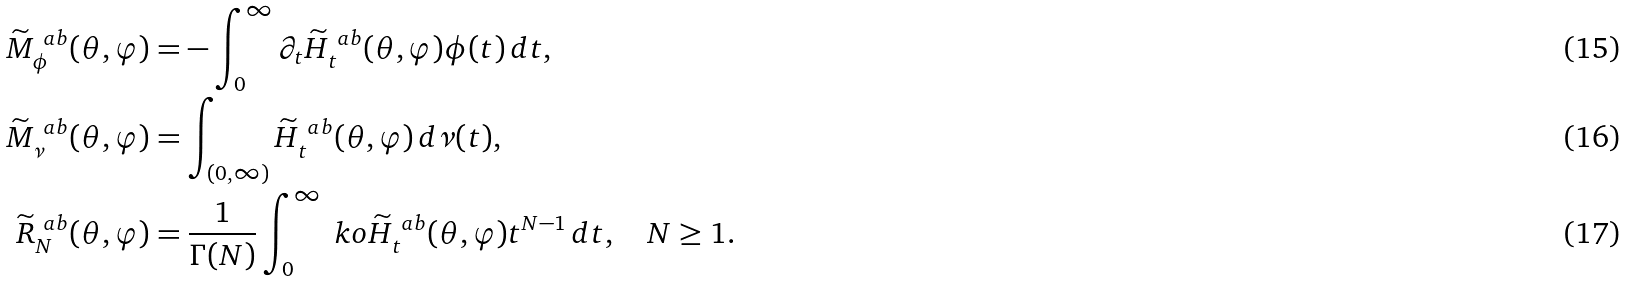Convert formula to latex. <formula><loc_0><loc_0><loc_500><loc_500>\widetilde { M } ^ { \ a b } _ { \phi } ( \theta , \varphi ) & = - \int _ { 0 } ^ { \infty } \partial _ { t } \widetilde { H } _ { t } ^ { \ a b } ( \theta , \varphi ) \phi ( t ) \, d t , \\ \widetilde { M } ^ { \ a b } _ { \nu } ( \theta , \varphi ) & = \int _ { ( 0 , \infty ) } \widetilde { H } _ { t } ^ { \ a b } ( \theta , \varphi ) \, d \nu ( t ) , \\ \widetilde { R } _ { N } ^ { \ a b } ( \theta , \varphi ) & = \frac { 1 } { \Gamma ( N ) } \int _ { 0 } ^ { \infty } \ k o \widetilde { H } _ { t } ^ { \ a b } ( \theta , \varphi ) t ^ { N - 1 } \, d t , \quad N \geq 1 .</formula> 